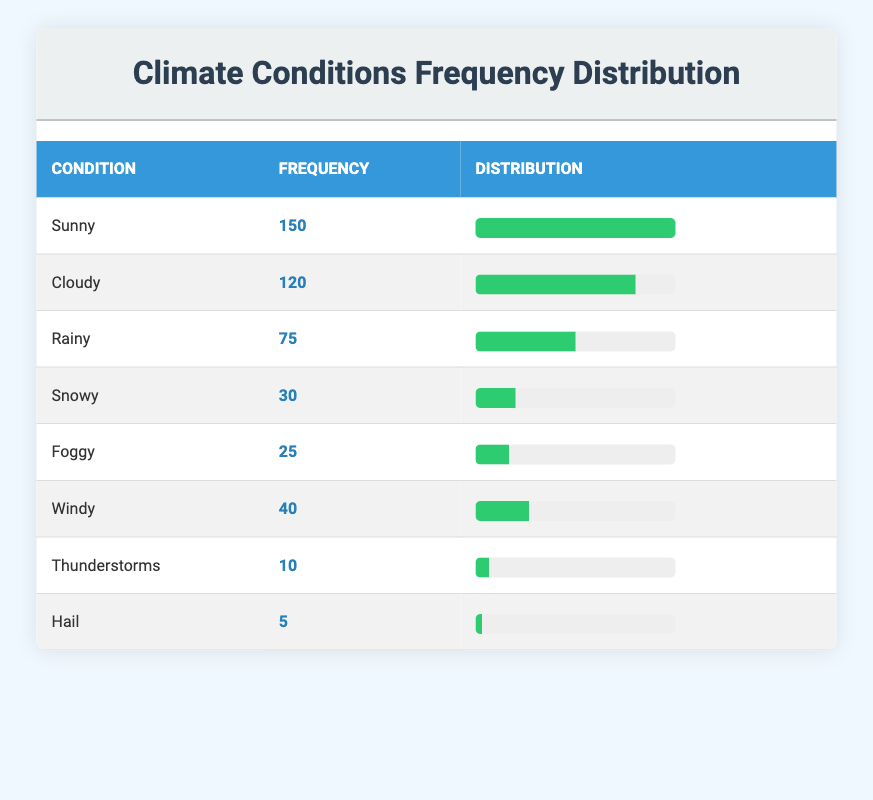What is the frequency of Sunny weather? The table lists the frequency of various climate conditions, where 'Sunny' has a frequency of 150.
Answer: 150 What climate condition has the lowest frequency? In the table, 'Hail' has the lowest frequency of 5 compared to other conditions.
Answer: Hail What is the total frequency of all weather conditions? To find the total frequency, we add up all the frequencies: 150 + 120 + 75 + 30 + 25 + 40 + 10 + 5 = 455.
Answer: 455 How many more times is Sunny weather recorded than Snowy weather? The frequency for 'Sunny' is 150 and for 'Snowy' it is 30. The difference is 150 - 30 = 120.
Answer: 120 Is the frequency of Thunderstorms greater than that of Rainy conditions? The frequency of 'Thunderstorms' is 10 while 'Rainy' has a frequency of 75. Since 10 is not greater than 75, the statement is false.
Answer: No What is the average frequency of the climate conditions listed? There are 8 conditions, and the total frequency is 455. To get the average, we divide 455 by 8, which equals approximately 56.875.
Answer: 56.875 Which two weather conditions have a combined frequency greater than 200? By analyzing the frequencies, 'Sunny' (150) and 'Cloudy' (120) add up to 270, which is greater than 200.
Answer: Yes What percentage of the total frequency does Foggy weather represent? The frequency for 'Foggy' is 25. To find the percentage of total frequency (455), we calculate (25 / 455) * 100, which is approximately 5.49%.
Answer: 5.49% What is the difference in frequency between Cloudy and Windy weather? The frequency for 'Cloudy' is 120 and for 'Windy' is 40. The difference is calculated by subtracting 40 from 120, which results in 80.
Answer: 80 